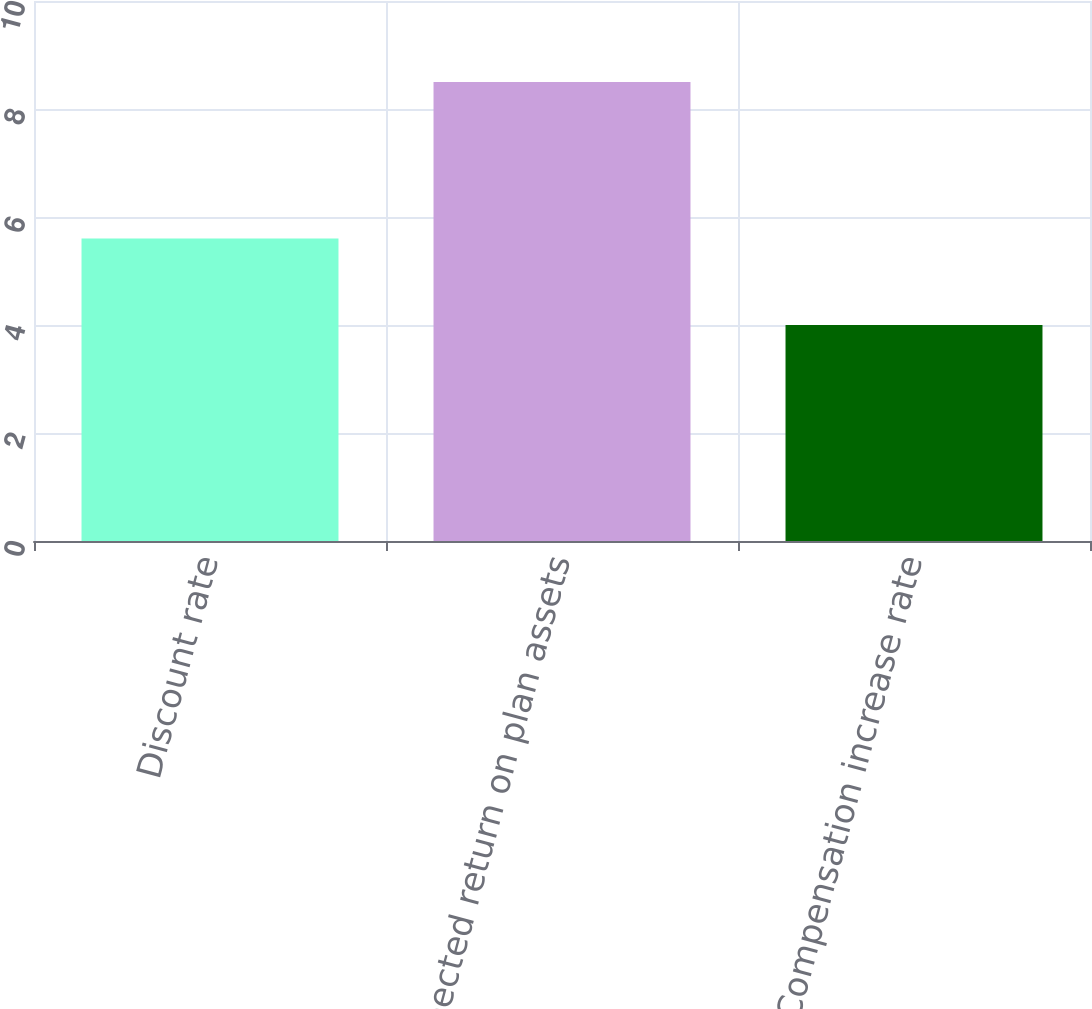Convert chart to OTSL. <chart><loc_0><loc_0><loc_500><loc_500><bar_chart><fcel>Discount rate<fcel>Expected return on plan assets<fcel>Compensation increase rate<nl><fcel>5.6<fcel>8.5<fcel>4<nl></chart> 